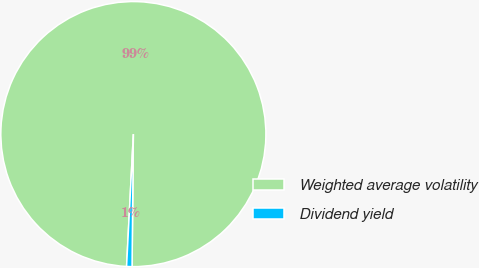Convert chart to OTSL. <chart><loc_0><loc_0><loc_500><loc_500><pie_chart><fcel>Weighted average volatility<fcel>Dividend yield<nl><fcel>99.34%<fcel>0.66%<nl></chart> 